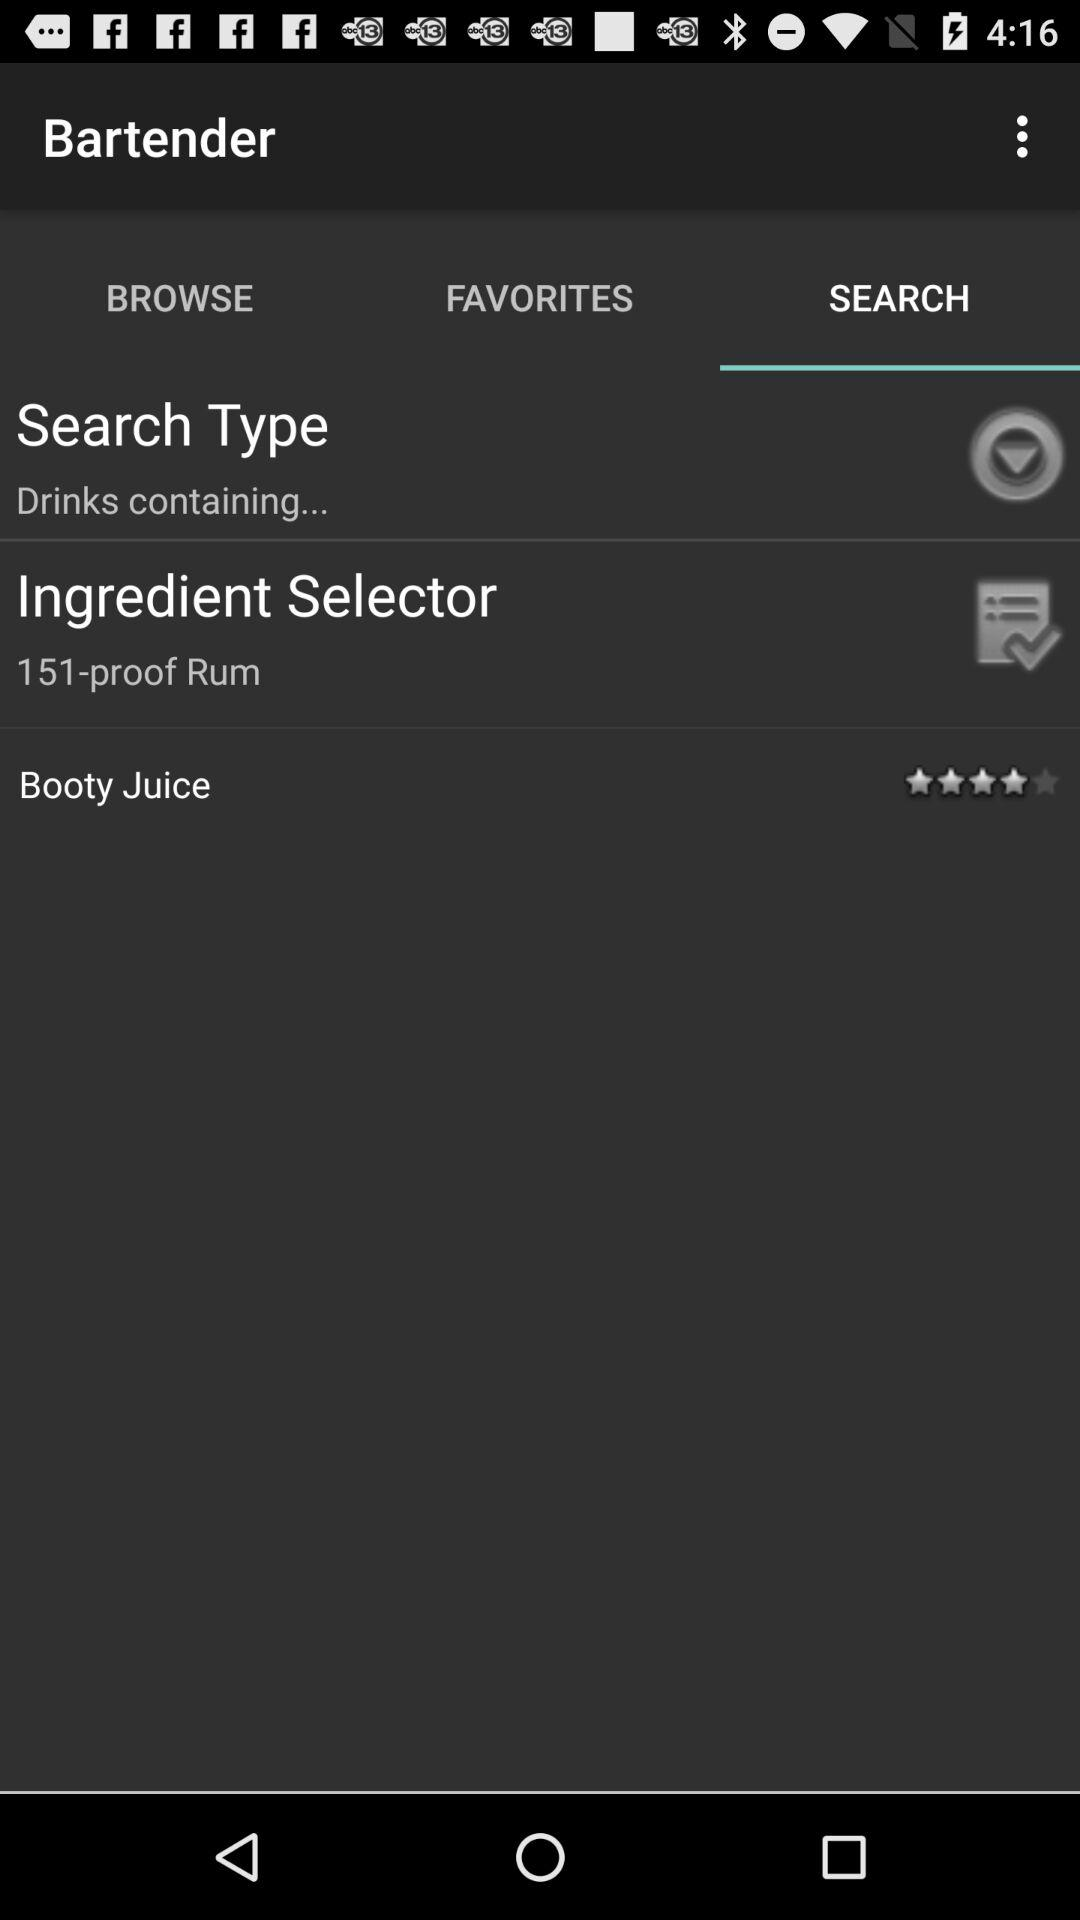Which tab has been selected? The selected tab is "SEARCH". 